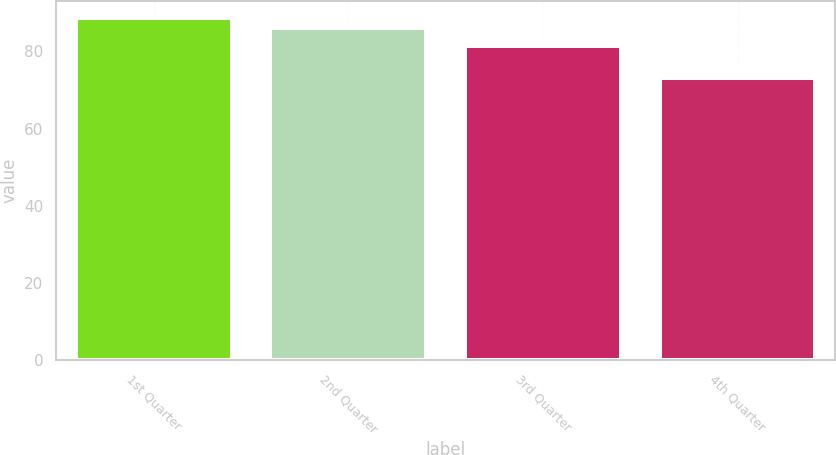Convert chart to OTSL. <chart><loc_0><loc_0><loc_500><loc_500><bar_chart><fcel>1st Quarter<fcel>2nd Quarter<fcel>3rd Quarter<fcel>4th Quarter<nl><fcel>88.56<fcel>86<fcel>81.43<fcel>73<nl></chart> 